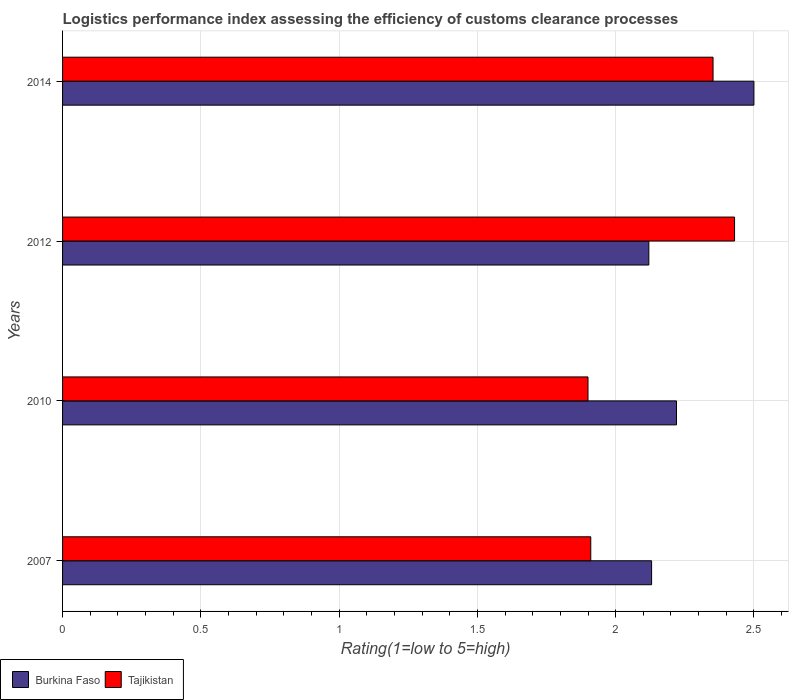Are the number of bars per tick equal to the number of legend labels?
Offer a very short reply. Yes. Are the number of bars on each tick of the Y-axis equal?
Give a very brief answer. Yes. How many bars are there on the 3rd tick from the top?
Give a very brief answer. 2. How many bars are there on the 4th tick from the bottom?
Make the answer very short. 2. In how many cases, is the number of bars for a given year not equal to the number of legend labels?
Offer a very short reply. 0. What is the Logistic performance index in Tajikistan in 2012?
Your response must be concise. 2.43. Across all years, what is the maximum Logistic performance index in Tajikistan?
Your answer should be very brief. 2.43. Across all years, what is the minimum Logistic performance index in Burkina Faso?
Give a very brief answer. 2.12. In which year was the Logistic performance index in Burkina Faso maximum?
Give a very brief answer. 2014. What is the total Logistic performance index in Burkina Faso in the graph?
Keep it short and to the point. 8.97. What is the difference between the Logistic performance index in Tajikistan in 2007 and that in 2014?
Give a very brief answer. -0.44. What is the difference between the Logistic performance index in Burkina Faso in 2007 and the Logistic performance index in Tajikistan in 2012?
Your answer should be very brief. -0.3. What is the average Logistic performance index in Tajikistan per year?
Give a very brief answer. 2.15. In the year 2014, what is the difference between the Logistic performance index in Tajikistan and Logistic performance index in Burkina Faso?
Make the answer very short. -0.15. In how many years, is the Logistic performance index in Burkina Faso greater than 1.5 ?
Your answer should be compact. 4. What is the ratio of the Logistic performance index in Burkina Faso in 2010 to that in 2012?
Make the answer very short. 1.05. What is the difference between the highest and the second highest Logistic performance index in Burkina Faso?
Your response must be concise. 0.28. What is the difference between the highest and the lowest Logistic performance index in Burkina Faso?
Your response must be concise. 0.38. In how many years, is the Logistic performance index in Burkina Faso greater than the average Logistic performance index in Burkina Faso taken over all years?
Offer a terse response. 1. What does the 2nd bar from the top in 2010 represents?
Your answer should be very brief. Burkina Faso. What does the 1st bar from the bottom in 2014 represents?
Provide a succinct answer. Burkina Faso. How many years are there in the graph?
Keep it short and to the point. 4. What is the difference between two consecutive major ticks on the X-axis?
Offer a very short reply. 0.5. Does the graph contain grids?
Keep it short and to the point. Yes. Where does the legend appear in the graph?
Make the answer very short. Bottom left. How many legend labels are there?
Provide a succinct answer. 2. What is the title of the graph?
Provide a short and direct response. Logistics performance index assessing the efficiency of customs clearance processes. Does "Papua New Guinea" appear as one of the legend labels in the graph?
Offer a terse response. No. What is the label or title of the X-axis?
Offer a very short reply. Rating(1=low to 5=high). What is the label or title of the Y-axis?
Your response must be concise. Years. What is the Rating(1=low to 5=high) in Burkina Faso in 2007?
Give a very brief answer. 2.13. What is the Rating(1=low to 5=high) in Tajikistan in 2007?
Your response must be concise. 1.91. What is the Rating(1=low to 5=high) in Burkina Faso in 2010?
Keep it short and to the point. 2.22. What is the Rating(1=low to 5=high) of Tajikistan in 2010?
Your answer should be compact. 1.9. What is the Rating(1=low to 5=high) in Burkina Faso in 2012?
Offer a very short reply. 2.12. What is the Rating(1=low to 5=high) of Tajikistan in 2012?
Offer a terse response. 2.43. What is the Rating(1=low to 5=high) in Tajikistan in 2014?
Offer a very short reply. 2.35. Across all years, what is the maximum Rating(1=low to 5=high) of Burkina Faso?
Keep it short and to the point. 2.5. Across all years, what is the maximum Rating(1=low to 5=high) of Tajikistan?
Provide a succinct answer. 2.43. Across all years, what is the minimum Rating(1=low to 5=high) of Burkina Faso?
Offer a very short reply. 2.12. What is the total Rating(1=low to 5=high) in Burkina Faso in the graph?
Give a very brief answer. 8.97. What is the total Rating(1=low to 5=high) of Tajikistan in the graph?
Provide a succinct answer. 8.59. What is the difference between the Rating(1=low to 5=high) of Burkina Faso in 2007 and that in 2010?
Your answer should be very brief. -0.09. What is the difference between the Rating(1=low to 5=high) in Tajikistan in 2007 and that in 2010?
Keep it short and to the point. 0.01. What is the difference between the Rating(1=low to 5=high) in Tajikistan in 2007 and that in 2012?
Provide a succinct answer. -0.52. What is the difference between the Rating(1=low to 5=high) in Burkina Faso in 2007 and that in 2014?
Make the answer very short. -0.37. What is the difference between the Rating(1=low to 5=high) of Tajikistan in 2007 and that in 2014?
Give a very brief answer. -0.44. What is the difference between the Rating(1=low to 5=high) in Tajikistan in 2010 and that in 2012?
Offer a very short reply. -0.53. What is the difference between the Rating(1=low to 5=high) in Burkina Faso in 2010 and that in 2014?
Make the answer very short. -0.28. What is the difference between the Rating(1=low to 5=high) in Tajikistan in 2010 and that in 2014?
Ensure brevity in your answer.  -0.45. What is the difference between the Rating(1=low to 5=high) in Burkina Faso in 2012 and that in 2014?
Make the answer very short. -0.38. What is the difference between the Rating(1=low to 5=high) of Tajikistan in 2012 and that in 2014?
Provide a short and direct response. 0.08. What is the difference between the Rating(1=low to 5=high) of Burkina Faso in 2007 and the Rating(1=low to 5=high) of Tajikistan in 2010?
Give a very brief answer. 0.23. What is the difference between the Rating(1=low to 5=high) of Burkina Faso in 2007 and the Rating(1=low to 5=high) of Tajikistan in 2012?
Your answer should be very brief. -0.3. What is the difference between the Rating(1=low to 5=high) in Burkina Faso in 2007 and the Rating(1=low to 5=high) in Tajikistan in 2014?
Offer a very short reply. -0.22. What is the difference between the Rating(1=low to 5=high) of Burkina Faso in 2010 and the Rating(1=low to 5=high) of Tajikistan in 2012?
Provide a short and direct response. -0.21. What is the difference between the Rating(1=low to 5=high) in Burkina Faso in 2010 and the Rating(1=low to 5=high) in Tajikistan in 2014?
Your response must be concise. -0.13. What is the difference between the Rating(1=low to 5=high) of Burkina Faso in 2012 and the Rating(1=low to 5=high) of Tajikistan in 2014?
Your response must be concise. -0.23. What is the average Rating(1=low to 5=high) of Burkina Faso per year?
Ensure brevity in your answer.  2.24. What is the average Rating(1=low to 5=high) in Tajikistan per year?
Offer a terse response. 2.15. In the year 2007, what is the difference between the Rating(1=low to 5=high) of Burkina Faso and Rating(1=low to 5=high) of Tajikistan?
Your answer should be very brief. 0.22. In the year 2010, what is the difference between the Rating(1=low to 5=high) of Burkina Faso and Rating(1=low to 5=high) of Tajikistan?
Provide a succinct answer. 0.32. In the year 2012, what is the difference between the Rating(1=low to 5=high) of Burkina Faso and Rating(1=low to 5=high) of Tajikistan?
Your answer should be compact. -0.31. In the year 2014, what is the difference between the Rating(1=low to 5=high) in Burkina Faso and Rating(1=low to 5=high) in Tajikistan?
Keep it short and to the point. 0.15. What is the ratio of the Rating(1=low to 5=high) in Burkina Faso in 2007 to that in 2010?
Give a very brief answer. 0.96. What is the ratio of the Rating(1=low to 5=high) in Tajikistan in 2007 to that in 2010?
Offer a very short reply. 1.01. What is the ratio of the Rating(1=low to 5=high) of Burkina Faso in 2007 to that in 2012?
Your answer should be compact. 1. What is the ratio of the Rating(1=low to 5=high) of Tajikistan in 2007 to that in 2012?
Your answer should be compact. 0.79. What is the ratio of the Rating(1=low to 5=high) in Burkina Faso in 2007 to that in 2014?
Your response must be concise. 0.85. What is the ratio of the Rating(1=low to 5=high) of Tajikistan in 2007 to that in 2014?
Offer a very short reply. 0.81. What is the ratio of the Rating(1=low to 5=high) of Burkina Faso in 2010 to that in 2012?
Ensure brevity in your answer.  1.05. What is the ratio of the Rating(1=low to 5=high) of Tajikistan in 2010 to that in 2012?
Provide a short and direct response. 0.78. What is the ratio of the Rating(1=low to 5=high) in Burkina Faso in 2010 to that in 2014?
Give a very brief answer. 0.89. What is the ratio of the Rating(1=low to 5=high) in Tajikistan in 2010 to that in 2014?
Provide a succinct answer. 0.81. What is the ratio of the Rating(1=low to 5=high) in Burkina Faso in 2012 to that in 2014?
Give a very brief answer. 0.85. What is the ratio of the Rating(1=low to 5=high) of Tajikistan in 2012 to that in 2014?
Keep it short and to the point. 1.03. What is the difference between the highest and the second highest Rating(1=low to 5=high) in Burkina Faso?
Give a very brief answer. 0.28. What is the difference between the highest and the second highest Rating(1=low to 5=high) of Tajikistan?
Offer a terse response. 0.08. What is the difference between the highest and the lowest Rating(1=low to 5=high) in Burkina Faso?
Offer a terse response. 0.38. What is the difference between the highest and the lowest Rating(1=low to 5=high) in Tajikistan?
Provide a succinct answer. 0.53. 